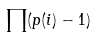Convert formula to latex. <formula><loc_0><loc_0><loc_500><loc_500>\prod ( p ( i ) - 1 )</formula> 